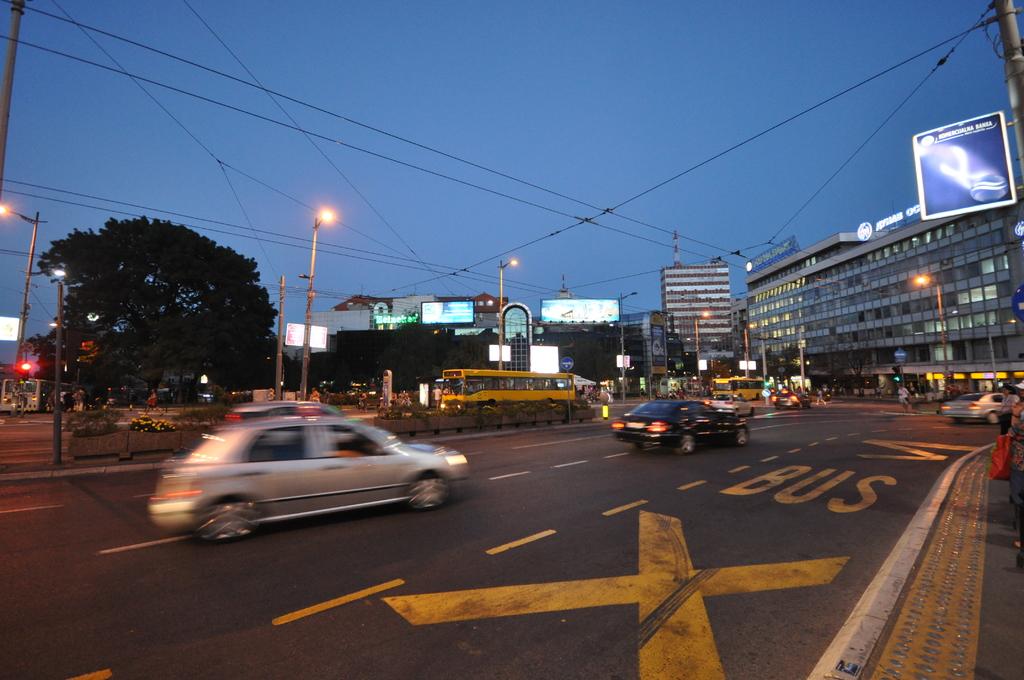What is the right lane for?
Ensure brevity in your answer.  Bus. What is the large yellow letter displayed at the bottom?
Offer a terse response. X. 